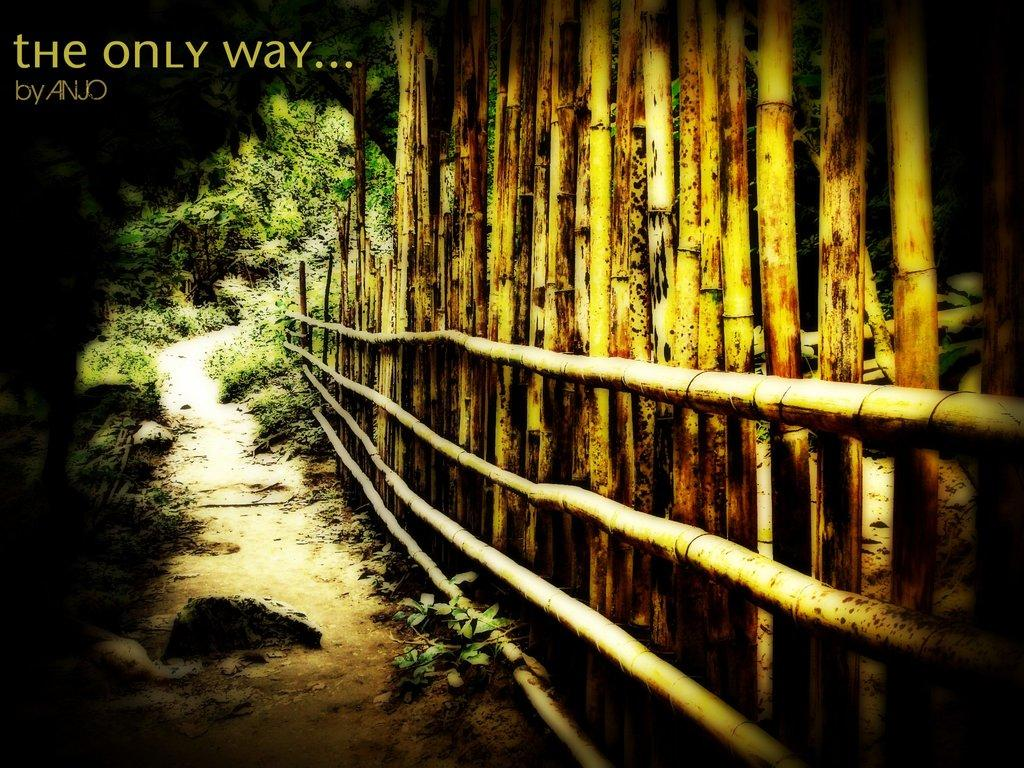What type of fencing is on the right side of the image? There is bamboo fencing on the right side of the image. What can be seen in the background of the image? There are trees in the background of the image. What type of stick can be seen being used for a game of catch in the image? There is no stick or game of catch present in the image. What type of ball is visible in the image? There is no ball present in the image. 